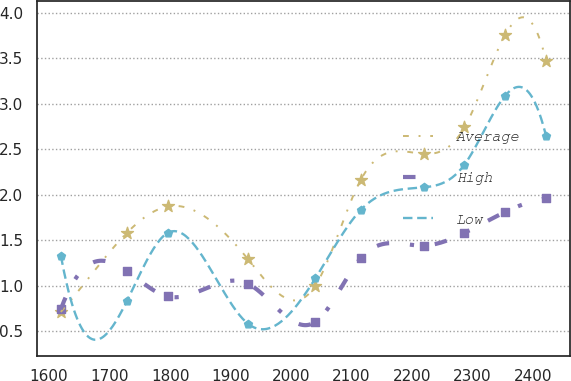Convert chart to OTSL. <chart><loc_0><loc_0><loc_500><loc_500><line_chart><ecel><fcel>Average<fcel>High<fcel>Low<nl><fcel>1619.41<fcel>0.71<fcel>0.74<fcel>1.33<nl><fcel>1728.63<fcel>1.58<fcel>1.16<fcel>0.83<nl><fcel>1796.18<fcel>1.87<fcel>0.88<fcel>1.58<nl><fcel>1928.84<fcel>1.29<fcel>1.02<fcel>0.58<nl><fcel>2040.19<fcel>1<fcel>0.6<fcel>1.08<nl><fcel>2114.95<fcel>2.16<fcel>1.3<fcel>1.83<nl><fcel>2219.03<fcel>2.45<fcel>1.44<fcel>2.08<nl><fcel>2286.58<fcel>2.74<fcel>1.58<fcel>2.33<nl><fcel>2354.13<fcel>3.76<fcel>1.81<fcel>3.09<nl><fcel>2421.68<fcel>3.47<fcel>1.96<fcel>2.64<nl></chart> 